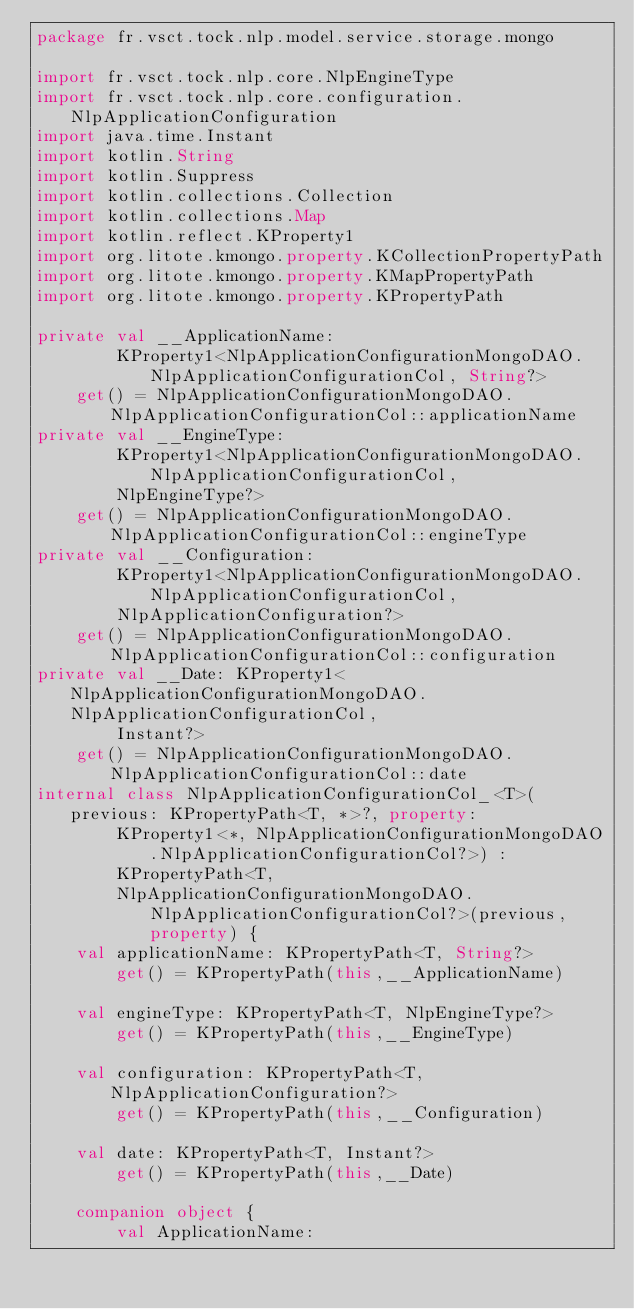<code> <loc_0><loc_0><loc_500><loc_500><_Kotlin_>package fr.vsct.tock.nlp.model.service.storage.mongo

import fr.vsct.tock.nlp.core.NlpEngineType
import fr.vsct.tock.nlp.core.configuration.NlpApplicationConfiguration
import java.time.Instant
import kotlin.String
import kotlin.Suppress
import kotlin.collections.Collection
import kotlin.collections.Map
import kotlin.reflect.KProperty1
import org.litote.kmongo.property.KCollectionPropertyPath
import org.litote.kmongo.property.KMapPropertyPath
import org.litote.kmongo.property.KPropertyPath

private val __ApplicationName:
        KProperty1<NlpApplicationConfigurationMongoDAO.NlpApplicationConfigurationCol, String?>
    get() = NlpApplicationConfigurationMongoDAO.NlpApplicationConfigurationCol::applicationName
private val __EngineType:
        KProperty1<NlpApplicationConfigurationMongoDAO.NlpApplicationConfigurationCol,
        NlpEngineType?>
    get() = NlpApplicationConfigurationMongoDAO.NlpApplicationConfigurationCol::engineType
private val __Configuration:
        KProperty1<NlpApplicationConfigurationMongoDAO.NlpApplicationConfigurationCol,
        NlpApplicationConfiguration?>
    get() = NlpApplicationConfigurationMongoDAO.NlpApplicationConfigurationCol::configuration
private val __Date: KProperty1<NlpApplicationConfigurationMongoDAO.NlpApplicationConfigurationCol,
        Instant?>
    get() = NlpApplicationConfigurationMongoDAO.NlpApplicationConfigurationCol::date
internal class NlpApplicationConfigurationCol_<T>(previous: KPropertyPath<T, *>?, property:
        KProperty1<*, NlpApplicationConfigurationMongoDAO.NlpApplicationConfigurationCol?>) :
        KPropertyPath<T,
        NlpApplicationConfigurationMongoDAO.NlpApplicationConfigurationCol?>(previous,property) {
    val applicationName: KPropertyPath<T, String?>
        get() = KPropertyPath(this,__ApplicationName)

    val engineType: KPropertyPath<T, NlpEngineType?>
        get() = KPropertyPath(this,__EngineType)

    val configuration: KPropertyPath<T, NlpApplicationConfiguration?>
        get() = KPropertyPath(this,__Configuration)

    val date: KPropertyPath<T, Instant?>
        get() = KPropertyPath(this,__Date)

    companion object {
        val ApplicationName:</code> 